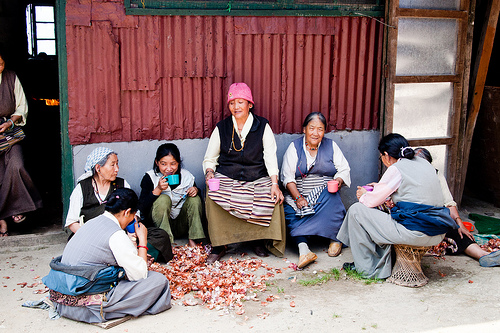<image>
Is the woman to the left of the woman? Yes. From this viewpoint, the woman is positioned to the left side relative to the woman. 